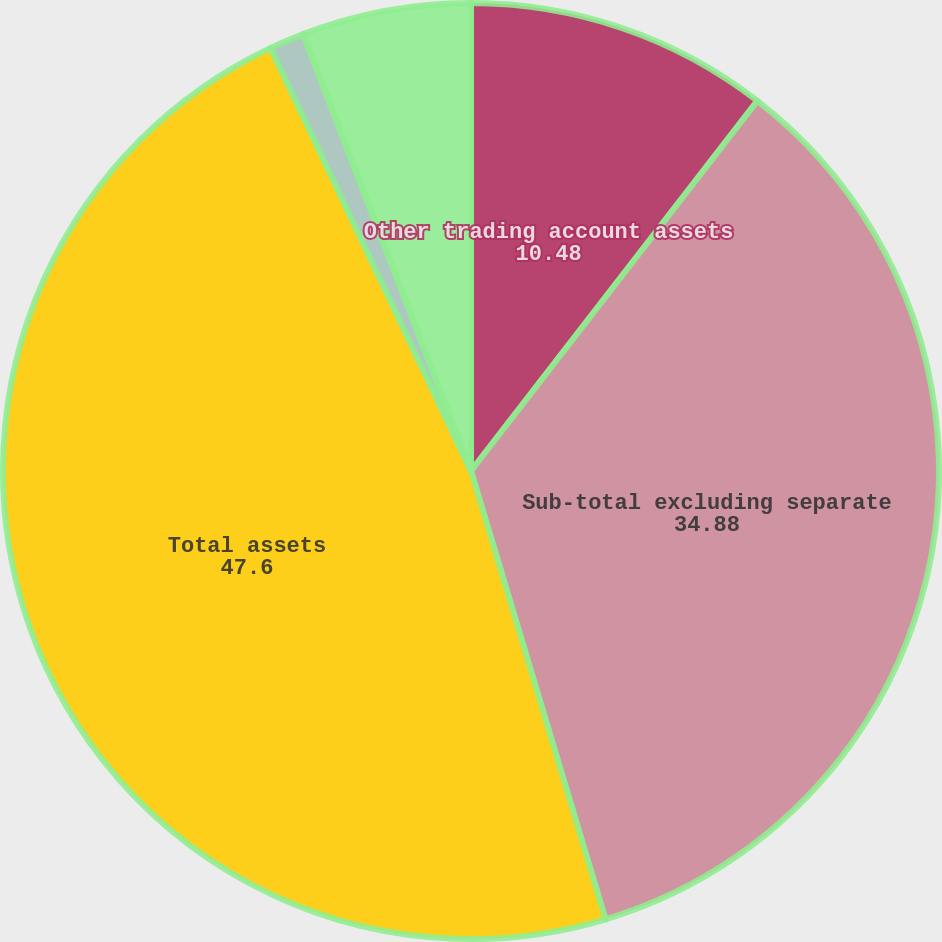<chart> <loc_0><loc_0><loc_500><loc_500><pie_chart><fcel>Other trading account assets<fcel>Sub-total excluding separate<fcel>Total assets<fcel>Other liabilities<fcel>Total liabilities<nl><fcel>10.48%<fcel>34.88%<fcel>47.6%<fcel>1.2%<fcel>5.84%<nl></chart> 